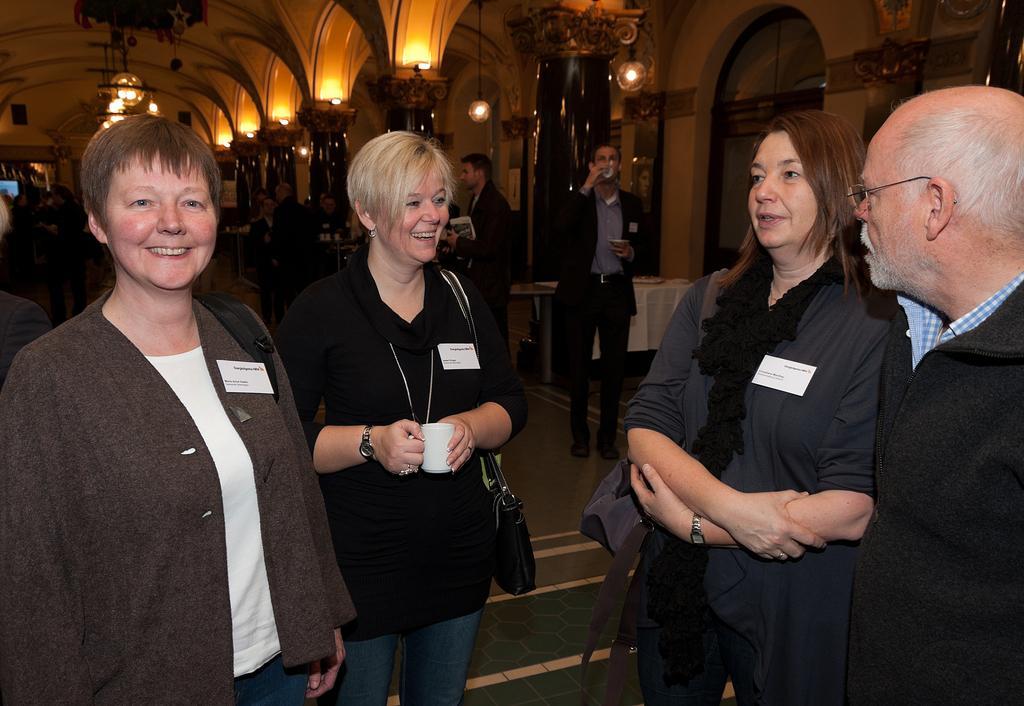Could you give a brief overview of what you see in this image? In this image I can see number of people are standing and I can see few of them are carrying bags. I can also see few people are holding mugs. I can also see most of them are wearing black colour of dress. I can also see see white colour papers on their dresses and on these papers I can see something is written. In the background I can see number of lights and in the front I can see two persons are smiling. 